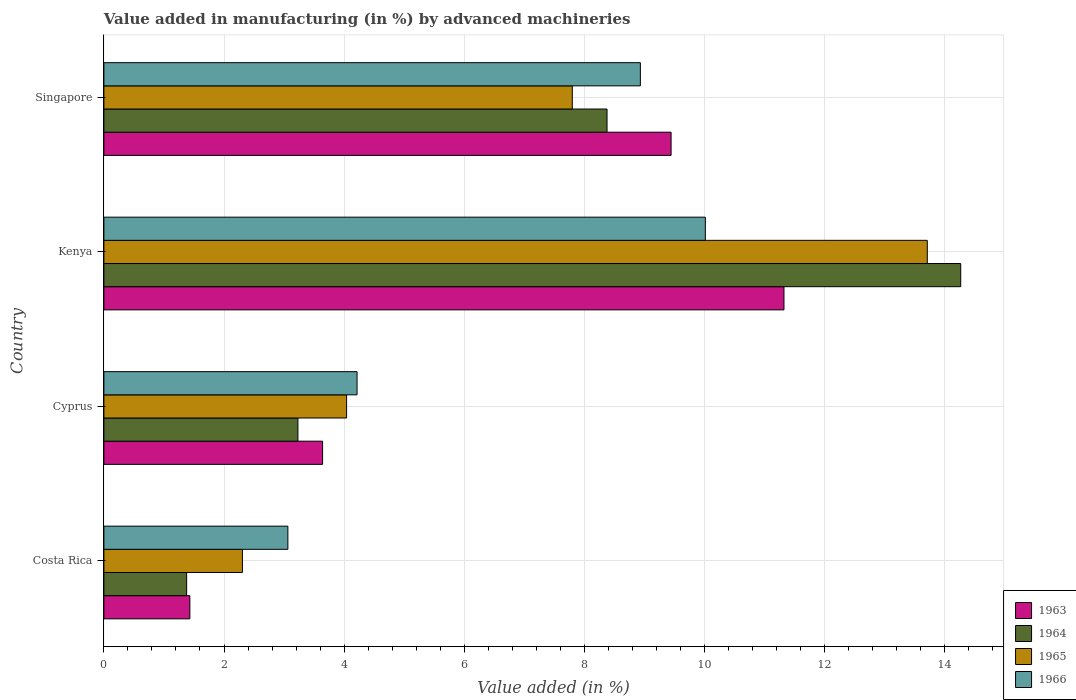How many groups of bars are there?
Make the answer very short. 4. Are the number of bars on each tick of the Y-axis equal?
Make the answer very short. Yes. How many bars are there on the 2nd tick from the top?
Provide a succinct answer. 4. How many bars are there on the 4th tick from the bottom?
Offer a terse response. 4. What is the label of the 3rd group of bars from the top?
Provide a short and direct response. Cyprus. What is the percentage of value added in manufacturing by advanced machineries in 1964 in Kenya?
Your answer should be very brief. 14.27. Across all countries, what is the maximum percentage of value added in manufacturing by advanced machineries in 1966?
Your response must be concise. 10.01. Across all countries, what is the minimum percentage of value added in manufacturing by advanced machineries in 1964?
Make the answer very short. 1.38. In which country was the percentage of value added in manufacturing by advanced machineries in 1965 maximum?
Provide a succinct answer. Kenya. In which country was the percentage of value added in manufacturing by advanced machineries in 1963 minimum?
Offer a terse response. Costa Rica. What is the total percentage of value added in manufacturing by advanced machineries in 1964 in the graph?
Your answer should be compact. 27.25. What is the difference between the percentage of value added in manufacturing by advanced machineries in 1964 in Costa Rica and that in Cyprus?
Give a very brief answer. -1.85. What is the difference between the percentage of value added in manufacturing by advanced machineries in 1963 in Cyprus and the percentage of value added in manufacturing by advanced machineries in 1964 in Costa Rica?
Provide a short and direct response. 2.26. What is the average percentage of value added in manufacturing by advanced machineries in 1963 per country?
Provide a short and direct response. 6.46. What is the difference between the percentage of value added in manufacturing by advanced machineries in 1964 and percentage of value added in manufacturing by advanced machineries in 1965 in Kenya?
Offer a terse response. 0.56. In how many countries, is the percentage of value added in manufacturing by advanced machineries in 1963 greater than 1.2000000000000002 %?
Offer a very short reply. 4. What is the ratio of the percentage of value added in manufacturing by advanced machineries in 1965 in Cyprus to that in Singapore?
Make the answer very short. 0.52. What is the difference between the highest and the second highest percentage of value added in manufacturing by advanced machineries in 1964?
Your answer should be very brief. 5.89. What is the difference between the highest and the lowest percentage of value added in manufacturing by advanced machineries in 1964?
Provide a short and direct response. 12.89. In how many countries, is the percentage of value added in manufacturing by advanced machineries in 1965 greater than the average percentage of value added in manufacturing by advanced machineries in 1965 taken over all countries?
Your response must be concise. 2. What does the 2nd bar from the top in Kenya represents?
Your answer should be compact. 1965. What does the 4th bar from the bottom in Kenya represents?
Provide a short and direct response. 1966. Does the graph contain any zero values?
Give a very brief answer. No. Where does the legend appear in the graph?
Provide a short and direct response. Bottom right. What is the title of the graph?
Your answer should be very brief. Value added in manufacturing (in %) by advanced machineries. What is the label or title of the X-axis?
Offer a terse response. Value added (in %). What is the label or title of the Y-axis?
Your answer should be very brief. Country. What is the Value added (in %) in 1963 in Costa Rica?
Give a very brief answer. 1.43. What is the Value added (in %) in 1964 in Costa Rica?
Your answer should be compact. 1.38. What is the Value added (in %) of 1965 in Costa Rica?
Offer a terse response. 2.31. What is the Value added (in %) in 1966 in Costa Rica?
Your response must be concise. 3.06. What is the Value added (in %) of 1963 in Cyprus?
Give a very brief answer. 3.64. What is the Value added (in %) of 1964 in Cyprus?
Provide a short and direct response. 3.23. What is the Value added (in %) of 1965 in Cyprus?
Your answer should be compact. 4.04. What is the Value added (in %) of 1966 in Cyprus?
Make the answer very short. 4.22. What is the Value added (in %) in 1963 in Kenya?
Your response must be concise. 11.32. What is the Value added (in %) in 1964 in Kenya?
Provide a succinct answer. 14.27. What is the Value added (in %) in 1965 in Kenya?
Keep it short and to the point. 13.71. What is the Value added (in %) of 1966 in Kenya?
Offer a very short reply. 10.01. What is the Value added (in %) in 1963 in Singapore?
Your response must be concise. 9.44. What is the Value added (in %) in 1964 in Singapore?
Provide a short and direct response. 8.38. What is the Value added (in %) of 1965 in Singapore?
Your answer should be very brief. 7.8. What is the Value added (in %) in 1966 in Singapore?
Offer a very short reply. 8.93. Across all countries, what is the maximum Value added (in %) in 1963?
Ensure brevity in your answer.  11.32. Across all countries, what is the maximum Value added (in %) of 1964?
Offer a very short reply. 14.27. Across all countries, what is the maximum Value added (in %) in 1965?
Provide a succinct answer. 13.71. Across all countries, what is the maximum Value added (in %) in 1966?
Offer a very short reply. 10.01. Across all countries, what is the minimum Value added (in %) in 1963?
Provide a succinct answer. 1.43. Across all countries, what is the minimum Value added (in %) of 1964?
Your answer should be compact. 1.38. Across all countries, what is the minimum Value added (in %) of 1965?
Provide a succinct answer. 2.31. Across all countries, what is the minimum Value added (in %) of 1966?
Offer a terse response. 3.06. What is the total Value added (in %) in 1963 in the graph?
Provide a short and direct response. 25.84. What is the total Value added (in %) of 1964 in the graph?
Keep it short and to the point. 27.25. What is the total Value added (in %) in 1965 in the graph?
Offer a terse response. 27.86. What is the total Value added (in %) in 1966 in the graph?
Provide a succinct answer. 26.23. What is the difference between the Value added (in %) in 1963 in Costa Rica and that in Cyprus?
Your answer should be very brief. -2.21. What is the difference between the Value added (in %) in 1964 in Costa Rica and that in Cyprus?
Provide a short and direct response. -1.85. What is the difference between the Value added (in %) in 1965 in Costa Rica and that in Cyprus?
Keep it short and to the point. -1.73. What is the difference between the Value added (in %) in 1966 in Costa Rica and that in Cyprus?
Provide a succinct answer. -1.15. What is the difference between the Value added (in %) of 1963 in Costa Rica and that in Kenya?
Ensure brevity in your answer.  -9.89. What is the difference between the Value added (in %) in 1964 in Costa Rica and that in Kenya?
Your response must be concise. -12.89. What is the difference between the Value added (in %) of 1965 in Costa Rica and that in Kenya?
Provide a succinct answer. -11.4. What is the difference between the Value added (in %) of 1966 in Costa Rica and that in Kenya?
Your answer should be very brief. -6.95. What is the difference between the Value added (in %) of 1963 in Costa Rica and that in Singapore?
Provide a short and direct response. -8.01. What is the difference between the Value added (in %) of 1964 in Costa Rica and that in Singapore?
Offer a terse response. -7. What is the difference between the Value added (in %) of 1965 in Costa Rica and that in Singapore?
Offer a very short reply. -5.49. What is the difference between the Value added (in %) in 1966 in Costa Rica and that in Singapore?
Provide a succinct answer. -5.87. What is the difference between the Value added (in %) in 1963 in Cyprus and that in Kenya?
Offer a very short reply. -7.68. What is the difference between the Value added (in %) in 1964 in Cyprus and that in Kenya?
Your answer should be very brief. -11.04. What is the difference between the Value added (in %) in 1965 in Cyprus and that in Kenya?
Your answer should be compact. -9.67. What is the difference between the Value added (in %) in 1966 in Cyprus and that in Kenya?
Keep it short and to the point. -5.8. What is the difference between the Value added (in %) of 1963 in Cyprus and that in Singapore?
Your answer should be compact. -5.8. What is the difference between the Value added (in %) in 1964 in Cyprus and that in Singapore?
Provide a succinct answer. -5.15. What is the difference between the Value added (in %) of 1965 in Cyprus and that in Singapore?
Provide a short and direct response. -3.76. What is the difference between the Value added (in %) in 1966 in Cyprus and that in Singapore?
Make the answer very short. -4.72. What is the difference between the Value added (in %) in 1963 in Kenya and that in Singapore?
Give a very brief answer. 1.88. What is the difference between the Value added (in %) in 1964 in Kenya and that in Singapore?
Make the answer very short. 5.89. What is the difference between the Value added (in %) of 1965 in Kenya and that in Singapore?
Provide a short and direct response. 5.91. What is the difference between the Value added (in %) in 1966 in Kenya and that in Singapore?
Ensure brevity in your answer.  1.08. What is the difference between the Value added (in %) in 1963 in Costa Rica and the Value added (in %) in 1964 in Cyprus?
Make the answer very short. -1.8. What is the difference between the Value added (in %) in 1963 in Costa Rica and the Value added (in %) in 1965 in Cyprus?
Ensure brevity in your answer.  -2.61. What is the difference between the Value added (in %) in 1963 in Costa Rica and the Value added (in %) in 1966 in Cyprus?
Offer a terse response. -2.78. What is the difference between the Value added (in %) of 1964 in Costa Rica and the Value added (in %) of 1965 in Cyprus?
Your answer should be very brief. -2.66. What is the difference between the Value added (in %) in 1964 in Costa Rica and the Value added (in %) in 1966 in Cyprus?
Your response must be concise. -2.84. What is the difference between the Value added (in %) in 1965 in Costa Rica and the Value added (in %) in 1966 in Cyprus?
Provide a succinct answer. -1.91. What is the difference between the Value added (in %) of 1963 in Costa Rica and the Value added (in %) of 1964 in Kenya?
Provide a short and direct response. -12.84. What is the difference between the Value added (in %) of 1963 in Costa Rica and the Value added (in %) of 1965 in Kenya?
Your answer should be very brief. -12.28. What is the difference between the Value added (in %) in 1963 in Costa Rica and the Value added (in %) in 1966 in Kenya?
Keep it short and to the point. -8.58. What is the difference between the Value added (in %) of 1964 in Costa Rica and the Value added (in %) of 1965 in Kenya?
Provide a succinct answer. -12.33. What is the difference between the Value added (in %) in 1964 in Costa Rica and the Value added (in %) in 1966 in Kenya?
Offer a very short reply. -8.64. What is the difference between the Value added (in %) in 1965 in Costa Rica and the Value added (in %) in 1966 in Kenya?
Make the answer very short. -7.71. What is the difference between the Value added (in %) in 1963 in Costa Rica and the Value added (in %) in 1964 in Singapore?
Provide a succinct answer. -6.95. What is the difference between the Value added (in %) of 1963 in Costa Rica and the Value added (in %) of 1965 in Singapore?
Provide a short and direct response. -6.37. What is the difference between the Value added (in %) in 1963 in Costa Rica and the Value added (in %) in 1966 in Singapore?
Your response must be concise. -7.5. What is the difference between the Value added (in %) in 1964 in Costa Rica and the Value added (in %) in 1965 in Singapore?
Ensure brevity in your answer.  -6.42. What is the difference between the Value added (in %) in 1964 in Costa Rica and the Value added (in %) in 1966 in Singapore?
Offer a very short reply. -7.55. What is the difference between the Value added (in %) in 1965 in Costa Rica and the Value added (in %) in 1966 in Singapore?
Your answer should be compact. -6.63. What is the difference between the Value added (in %) of 1963 in Cyprus and the Value added (in %) of 1964 in Kenya?
Your answer should be compact. -10.63. What is the difference between the Value added (in %) of 1963 in Cyprus and the Value added (in %) of 1965 in Kenya?
Provide a succinct answer. -10.07. What is the difference between the Value added (in %) in 1963 in Cyprus and the Value added (in %) in 1966 in Kenya?
Offer a terse response. -6.37. What is the difference between the Value added (in %) of 1964 in Cyprus and the Value added (in %) of 1965 in Kenya?
Make the answer very short. -10.48. What is the difference between the Value added (in %) of 1964 in Cyprus and the Value added (in %) of 1966 in Kenya?
Provide a succinct answer. -6.78. What is the difference between the Value added (in %) of 1965 in Cyprus and the Value added (in %) of 1966 in Kenya?
Provide a short and direct response. -5.97. What is the difference between the Value added (in %) of 1963 in Cyprus and the Value added (in %) of 1964 in Singapore?
Keep it short and to the point. -4.74. What is the difference between the Value added (in %) in 1963 in Cyprus and the Value added (in %) in 1965 in Singapore?
Offer a very short reply. -4.16. What is the difference between the Value added (in %) of 1963 in Cyprus and the Value added (in %) of 1966 in Singapore?
Ensure brevity in your answer.  -5.29. What is the difference between the Value added (in %) of 1964 in Cyprus and the Value added (in %) of 1965 in Singapore?
Your response must be concise. -4.57. What is the difference between the Value added (in %) in 1964 in Cyprus and the Value added (in %) in 1966 in Singapore?
Your response must be concise. -5.7. What is the difference between the Value added (in %) in 1965 in Cyprus and the Value added (in %) in 1966 in Singapore?
Offer a terse response. -4.89. What is the difference between the Value added (in %) of 1963 in Kenya and the Value added (in %) of 1964 in Singapore?
Offer a terse response. 2.95. What is the difference between the Value added (in %) of 1963 in Kenya and the Value added (in %) of 1965 in Singapore?
Your answer should be compact. 3.52. What is the difference between the Value added (in %) in 1963 in Kenya and the Value added (in %) in 1966 in Singapore?
Offer a terse response. 2.39. What is the difference between the Value added (in %) in 1964 in Kenya and the Value added (in %) in 1965 in Singapore?
Keep it short and to the point. 6.47. What is the difference between the Value added (in %) of 1964 in Kenya and the Value added (in %) of 1966 in Singapore?
Your response must be concise. 5.33. What is the difference between the Value added (in %) of 1965 in Kenya and the Value added (in %) of 1966 in Singapore?
Provide a short and direct response. 4.78. What is the average Value added (in %) in 1963 per country?
Give a very brief answer. 6.46. What is the average Value added (in %) of 1964 per country?
Your answer should be compact. 6.81. What is the average Value added (in %) of 1965 per country?
Keep it short and to the point. 6.96. What is the average Value added (in %) of 1966 per country?
Your response must be concise. 6.56. What is the difference between the Value added (in %) in 1963 and Value added (in %) in 1964 in Costa Rica?
Your answer should be compact. 0.05. What is the difference between the Value added (in %) in 1963 and Value added (in %) in 1965 in Costa Rica?
Your answer should be very brief. -0.88. What is the difference between the Value added (in %) of 1963 and Value added (in %) of 1966 in Costa Rica?
Keep it short and to the point. -1.63. What is the difference between the Value added (in %) in 1964 and Value added (in %) in 1965 in Costa Rica?
Ensure brevity in your answer.  -0.93. What is the difference between the Value added (in %) in 1964 and Value added (in %) in 1966 in Costa Rica?
Give a very brief answer. -1.69. What is the difference between the Value added (in %) in 1965 and Value added (in %) in 1966 in Costa Rica?
Offer a very short reply. -0.76. What is the difference between the Value added (in %) of 1963 and Value added (in %) of 1964 in Cyprus?
Ensure brevity in your answer.  0.41. What is the difference between the Value added (in %) in 1963 and Value added (in %) in 1965 in Cyprus?
Keep it short and to the point. -0.4. What is the difference between the Value added (in %) in 1963 and Value added (in %) in 1966 in Cyprus?
Make the answer very short. -0.57. What is the difference between the Value added (in %) in 1964 and Value added (in %) in 1965 in Cyprus?
Provide a short and direct response. -0.81. What is the difference between the Value added (in %) of 1964 and Value added (in %) of 1966 in Cyprus?
Keep it short and to the point. -0.98. What is the difference between the Value added (in %) of 1965 and Value added (in %) of 1966 in Cyprus?
Keep it short and to the point. -0.17. What is the difference between the Value added (in %) in 1963 and Value added (in %) in 1964 in Kenya?
Your response must be concise. -2.94. What is the difference between the Value added (in %) of 1963 and Value added (in %) of 1965 in Kenya?
Give a very brief answer. -2.39. What is the difference between the Value added (in %) of 1963 and Value added (in %) of 1966 in Kenya?
Provide a succinct answer. 1.31. What is the difference between the Value added (in %) of 1964 and Value added (in %) of 1965 in Kenya?
Provide a short and direct response. 0.56. What is the difference between the Value added (in %) of 1964 and Value added (in %) of 1966 in Kenya?
Your response must be concise. 4.25. What is the difference between the Value added (in %) in 1965 and Value added (in %) in 1966 in Kenya?
Ensure brevity in your answer.  3.7. What is the difference between the Value added (in %) in 1963 and Value added (in %) in 1964 in Singapore?
Your answer should be compact. 1.07. What is the difference between the Value added (in %) of 1963 and Value added (in %) of 1965 in Singapore?
Offer a terse response. 1.64. What is the difference between the Value added (in %) of 1963 and Value added (in %) of 1966 in Singapore?
Ensure brevity in your answer.  0.51. What is the difference between the Value added (in %) in 1964 and Value added (in %) in 1965 in Singapore?
Offer a very short reply. 0.58. What is the difference between the Value added (in %) in 1964 and Value added (in %) in 1966 in Singapore?
Provide a succinct answer. -0.55. What is the difference between the Value added (in %) of 1965 and Value added (in %) of 1966 in Singapore?
Your answer should be very brief. -1.13. What is the ratio of the Value added (in %) in 1963 in Costa Rica to that in Cyprus?
Offer a very short reply. 0.39. What is the ratio of the Value added (in %) in 1964 in Costa Rica to that in Cyprus?
Keep it short and to the point. 0.43. What is the ratio of the Value added (in %) in 1965 in Costa Rica to that in Cyprus?
Your response must be concise. 0.57. What is the ratio of the Value added (in %) of 1966 in Costa Rica to that in Cyprus?
Keep it short and to the point. 0.73. What is the ratio of the Value added (in %) of 1963 in Costa Rica to that in Kenya?
Make the answer very short. 0.13. What is the ratio of the Value added (in %) in 1964 in Costa Rica to that in Kenya?
Keep it short and to the point. 0.1. What is the ratio of the Value added (in %) of 1965 in Costa Rica to that in Kenya?
Keep it short and to the point. 0.17. What is the ratio of the Value added (in %) in 1966 in Costa Rica to that in Kenya?
Provide a succinct answer. 0.31. What is the ratio of the Value added (in %) of 1963 in Costa Rica to that in Singapore?
Your answer should be very brief. 0.15. What is the ratio of the Value added (in %) of 1964 in Costa Rica to that in Singapore?
Your answer should be very brief. 0.16. What is the ratio of the Value added (in %) in 1965 in Costa Rica to that in Singapore?
Provide a succinct answer. 0.3. What is the ratio of the Value added (in %) in 1966 in Costa Rica to that in Singapore?
Your response must be concise. 0.34. What is the ratio of the Value added (in %) in 1963 in Cyprus to that in Kenya?
Provide a short and direct response. 0.32. What is the ratio of the Value added (in %) of 1964 in Cyprus to that in Kenya?
Offer a very short reply. 0.23. What is the ratio of the Value added (in %) of 1965 in Cyprus to that in Kenya?
Provide a succinct answer. 0.29. What is the ratio of the Value added (in %) in 1966 in Cyprus to that in Kenya?
Offer a very short reply. 0.42. What is the ratio of the Value added (in %) of 1963 in Cyprus to that in Singapore?
Offer a very short reply. 0.39. What is the ratio of the Value added (in %) of 1964 in Cyprus to that in Singapore?
Provide a short and direct response. 0.39. What is the ratio of the Value added (in %) in 1965 in Cyprus to that in Singapore?
Ensure brevity in your answer.  0.52. What is the ratio of the Value added (in %) of 1966 in Cyprus to that in Singapore?
Your response must be concise. 0.47. What is the ratio of the Value added (in %) of 1963 in Kenya to that in Singapore?
Offer a terse response. 1.2. What is the ratio of the Value added (in %) in 1964 in Kenya to that in Singapore?
Provide a short and direct response. 1.7. What is the ratio of the Value added (in %) of 1965 in Kenya to that in Singapore?
Make the answer very short. 1.76. What is the ratio of the Value added (in %) of 1966 in Kenya to that in Singapore?
Provide a short and direct response. 1.12. What is the difference between the highest and the second highest Value added (in %) in 1963?
Provide a succinct answer. 1.88. What is the difference between the highest and the second highest Value added (in %) in 1964?
Your answer should be compact. 5.89. What is the difference between the highest and the second highest Value added (in %) in 1965?
Your answer should be very brief. 5.91. What is the difference between the highest and the second highest Value added (in %) in 1966?
Your answer should be very brief. 1.08. What is the difference between the highest and the lowest Value added (in %) in 1963?
Give a very brief answer. 9.89. What is the difference between the highest and the lowest Value added (in %) in 1964?
Your answer should be very brief. 12.89. What is the difference between the highest and the lowest Value added (in %) in 1965?
Keep it short and to the point. 11.4. What is the difference between the highest and the lowest Value added (in %) of 1966?
Your answer should be compact. 6.95. 